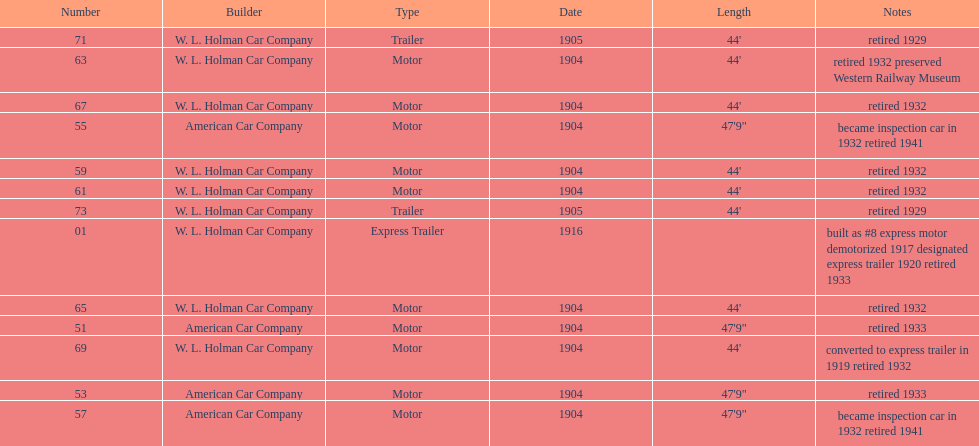What was the number of cars built by american car company? 4. 